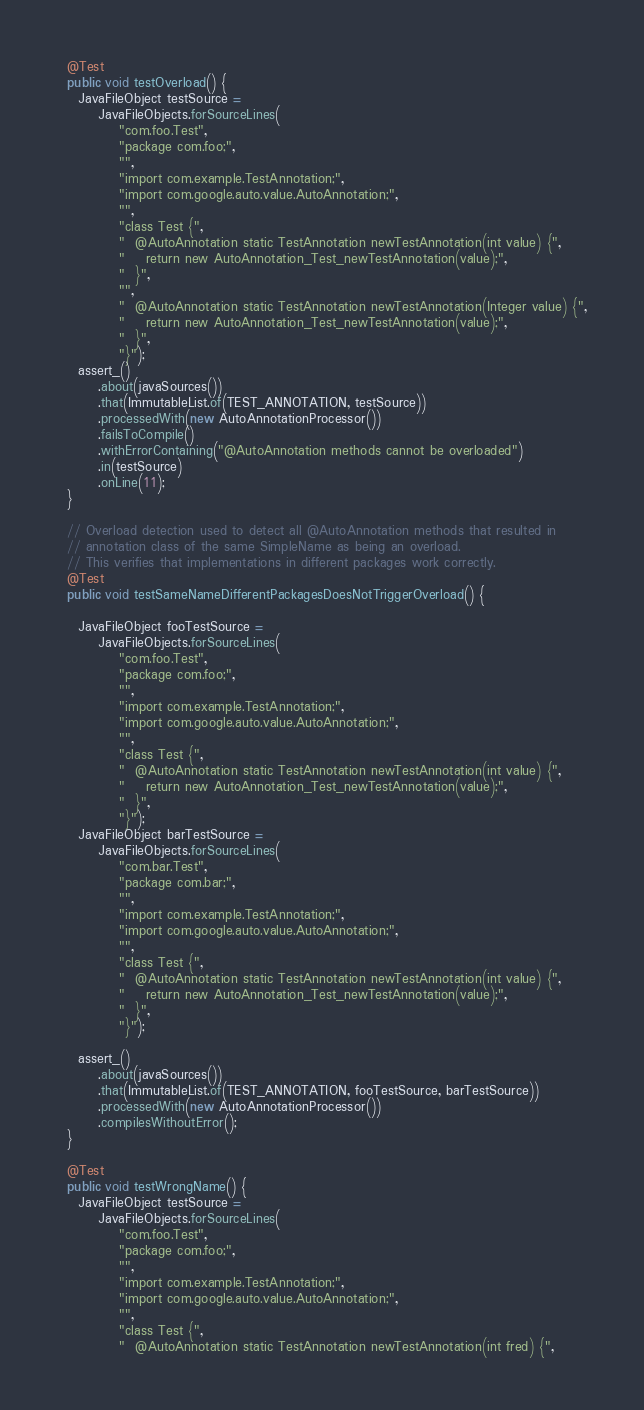<code> <loc_0><loc_0><loc_500><loc_500><_Java_>
  @Test
  public void testOverload() {
    JavaFileObject testSource =
        JavaFileObjects.forSourceLines(
            "com.foo.Test",
            "package com.foo;",
            "",
            "import com.example.TestAnnotation;",
            "import com.google.auto.value.AutoAnnotation;",
            "",
            "class Test {",
            "  @AutoAnnotation static TestAnnotation newTestAnnotation(int value) {",
            "    return new AutoAnnotation_Test_newTestAnnotation(value);",
            "  }",
            "",
            "  @AutoAnnotation static TestAnnotation newTestAnnotation(Integer value) {",
            "    return new AutoAnnotation_Test_newTestAnnotation(value);",
            "  }",
            "}");
    assert_()
        .about(javaSources())
        .that(ImmutableList.of(TEST_ANNOTATION, testSource))
        .processedWith(new AutoAnnotationProcessor())
        .failsToCompile()
        .withErrorContaining("@AutoAnnotation methods cannot be overloaded")
        .in(testSource)
        .onLine(11);
  }

  // Overload detection used to detect all @AutoAnnotation methods that resulted in
  // annotation class of the same SimpleName as being an overload.
  // This verifies that implementations in different packages work correctly.
  @Test
  public void testSameNameDifferentPackagesDoesNotTriggerOverload() {

    JavaFileObject fooTestSource =
        JavaFileObjects.forSourceLines(
            "com.foo.Test",
            "package com.foo;",
            "",
            "import com.example.TestAnnotation;",
            "import com.google.auto.value.AutoAnnotation;",
            "",
            "class Test {",
            "  @AutoAnnotation static TestAnnotation newTestAnnotation(int value) {",
            "    return new AutoAnnotation_Test_newTestAnnotation(value);",
            "  }",
            "}");
    JavaFileObject barTestSource =
        JavaFileObjects.forSourceLines(
            "com.bar.Test",
            "package com.bar;",
            "",
            "import com.example.TestAnnotation;",
            "import com.google.auto.value.AutoAnnotation;",
            "",
            "class Test {",
            "  @AutoAnnotation static TestAnnotation newTestAnnotation(int value) {",
            "    return new AutoAnnotation_Test_newTestAnnotation(value);",
            "  }",
            "}");

    assert_()
        .about(javaSources())
        .that(ImmutableList.of(TEST_ANNOTATION, fooTestSource, barTestSource))
        .processedWith(new AutoAnnotationProcessor())
        .compilesWithoutError();
  }

  @Test
  public void testWrongName() {
    JavaFileObject testSource =
        JavaFileObjects.forSourceLines(
            "com.foo.Test",
            "package com.foo;",
            "",
            "import com.example.TestAnnotation;",
            "import com.google.auto.value.AutoAnnotation;",
            "",
            "class Test {",
            "  @AutoAnnotation static TestAnnotation newTestAnnotation(int fred) {",</code> 